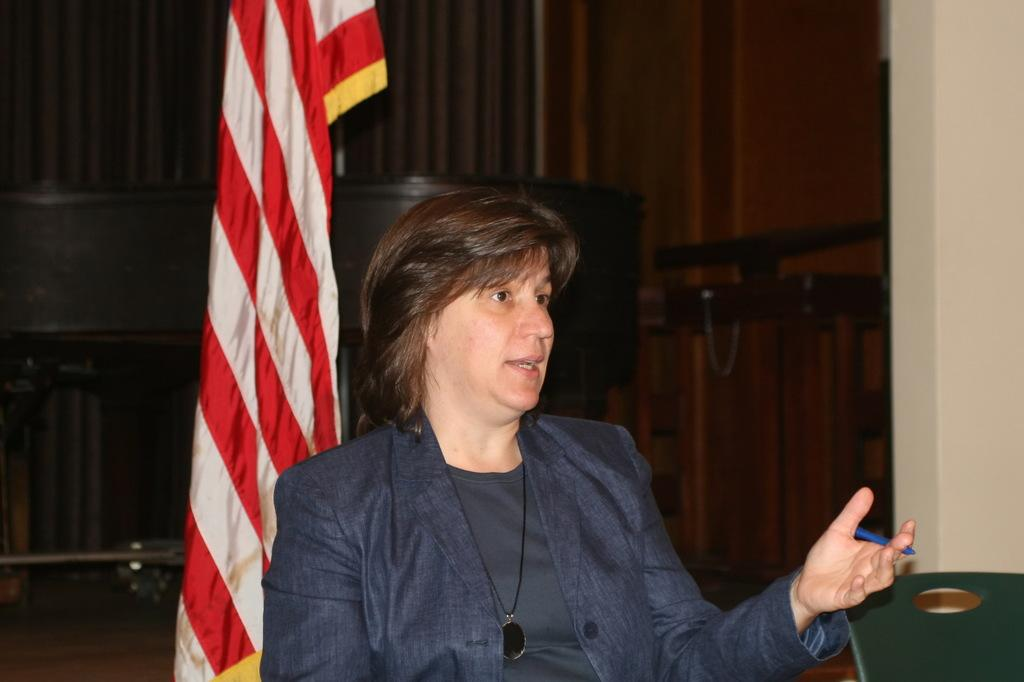What can be seen in the image? There is a person in the image. What is the person holding? The person is holding a pen. What is visible in the background of the image? There is a flag, a wall, and some objects in the background of the image. What type of boot can be seen on the person's foot in the image? There is no boot visible on the person's foot in the image. How many weeks have passed since the person last wrote with the pen? The image does not provide any information about the passage of time or the person's writing habits, so it is impossible to determine how many weeks have passed since the person last wrote with the pen. 